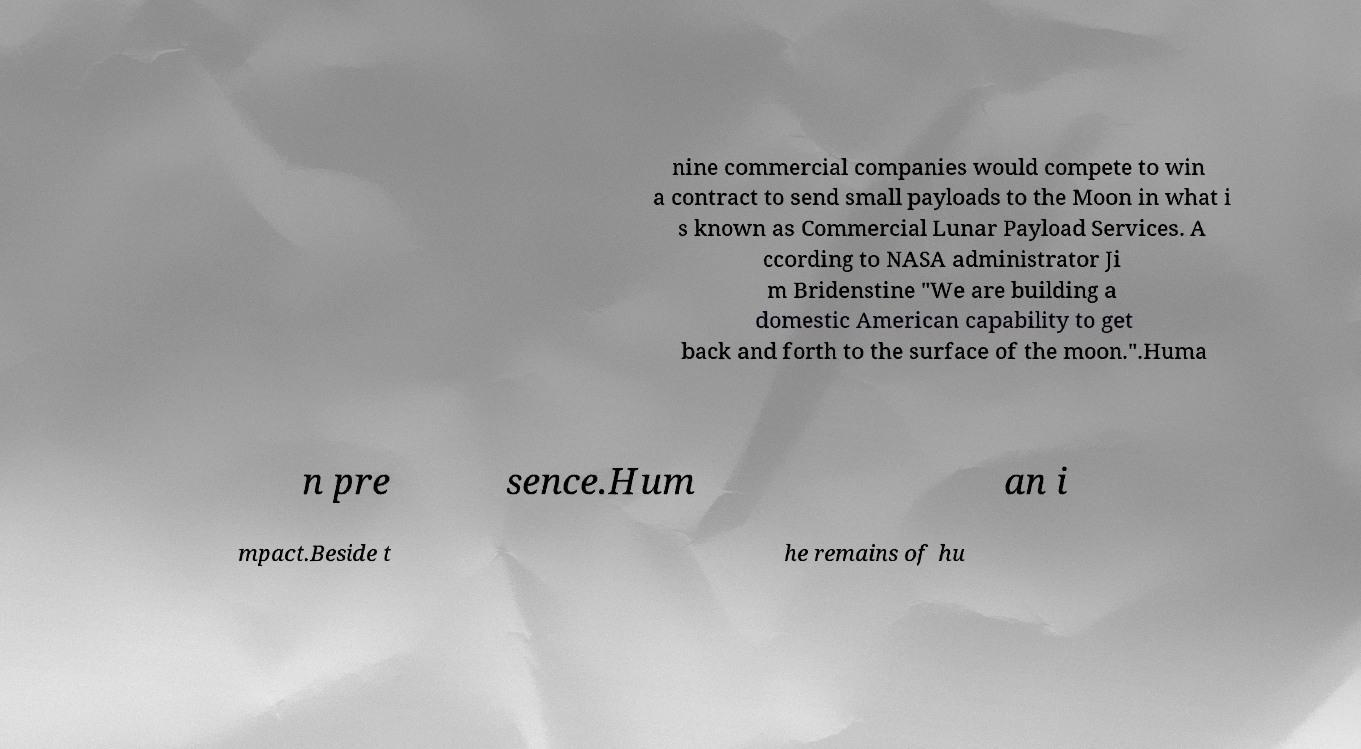There's text embedded in this image that I need extracted. Can you transcribe it verbatim? nine commercial companies would compete to win a contract to send small payloads to the Moon in what i s known as Commercial Lunar Payload Services. A ccording to NASA administrator Ji m Bridenstine "We are building a domestic American capability to get back and forth to the surface of the moon.".Huma n pre sence.Hum an i mpact.Beside t he remains of hu 